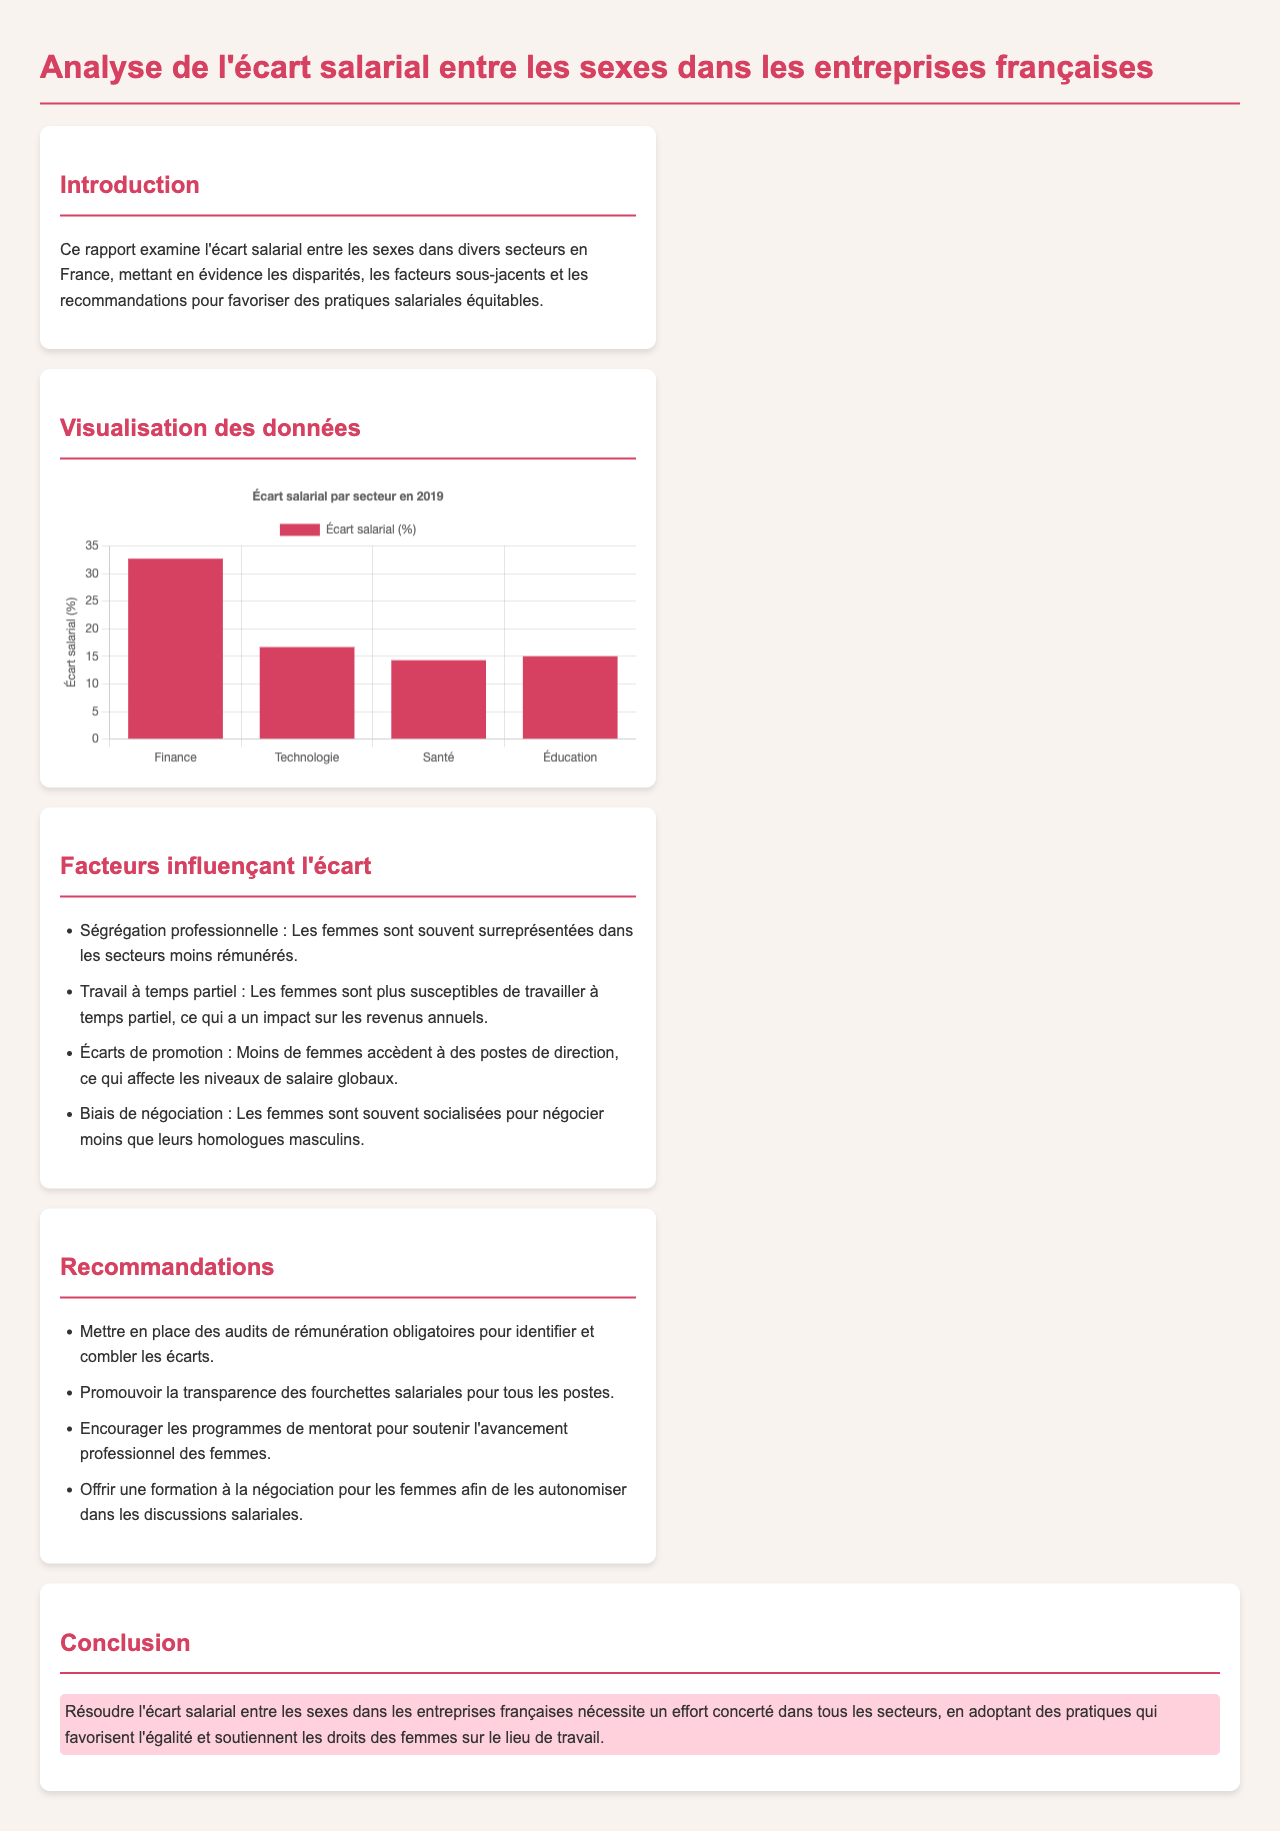Quel est le titre du rapport ? Le titre du rapport est indiqué dans la balise `<title>` de l'en-tête du document.
Answer: Analyse de l'écart salarial entre les sexes dans les entreprises françaises Quel est l'écart salarial dans le secteur de la finance ? Les données sont présentées dans le graphique, spécifiquement pour le secteur de la finance.
Answer: 32.69 Quels sont les facteurs influençant l'écart salarial ? Les facteurs sont listés dans la section 'Facteurs influençant l'écart' du rapport.
Answer: Ségrégation professionnelle, Travail à temps partiel, Écarts de promotion, Biais de négociation Quelle est la recommandation concernant les audits ? La recommandation relative aux audits est précisée dans la section 'Recommandations' du document.
Answer: Audits de rémunération obligatoires Combien de secteurs sont mentionnés dans la visualisation des données ? Le nombre de secteurs est indiqué par les étiquettes de données dans le graphique.
Answer: 4 Quel est le pourcentage d'écart salarial dans le secteur de la santé ? Le pourcentage spécifique pour le secteur de la santé est affiché dans le graphique.
Answer: 14.29 Quel est le message principal de la conclusion ? Le message principal est résumée dans la section 'Conclusion' du rapport.
Answer: Résoudre l'écart salarial entre les sexes nécessite un effort concerté Quel type de graphique est utilisé pour présenter les données ? Le type de graphique est décrit dans le contexte du script de la visualisation.
Answer: Bar 